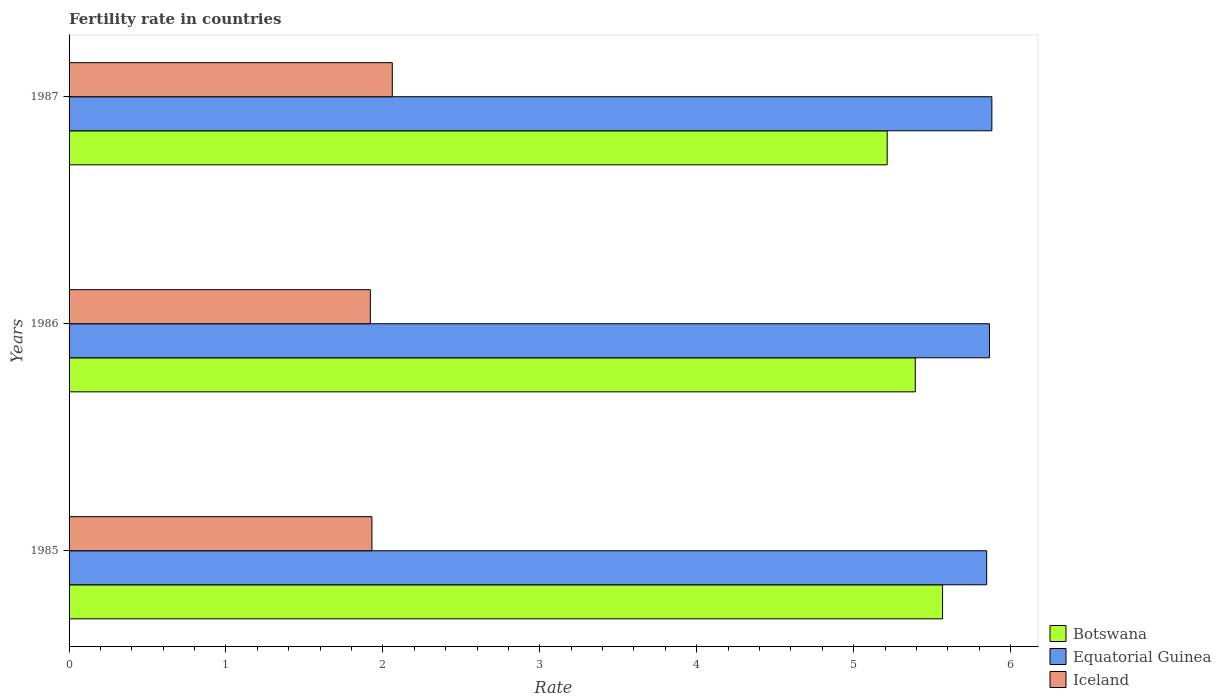How many different coloured bars are there?
Your answer should be compact. 3. How many groups of bars are there?
Keep it short and to the point. 3. What is the fertility rate in Iceland in 1985?
Offer a terse response. 1.93. Across all years, what is the maximum fertility rate in Botswana?
Ensure brevity in your answer.  5.57. Across all years, what is the minimum fertility rate in Equatorial Guinea?
Your response must be concise. 5.85. In which year was the fertility rate in Iceland minimum?
Your response must be concise. 1986. What is the total fertility rate in Iceland in the graph?
Your answer should be compact. 5.91. What is the difference between the fertility rate in Iceland in 1985 and that in 1987?
Offer a very short reply. -0.13. What is the difference between the fertility rate in Botswana in 1987 and the fertility rate in Iceland in 1985?
Keep it short and to the point. 3.28. What is the average fertility rate in Equatorial Guinea per year?
Make the answer very short. 5.87. In the year 1987, what is the difference between the fertility rate in Equatorial Guinea and fertility rate in Botswana?
Offer a very short reply. 0.67. In how many years, is the fertility rate in Equatorial Guinea greater than 4.8 ?
Ensure brevity in your answer.  3. What is the ratio of the fertility rate in Iceland in 1985 to that in 1986?
Provide a short and direct response. 1.01. Is the fertility rate in Botswana in 1985 less than that in 1986?
Ensure brevity in your answer.  No. Is the difference between the fertility rate in Equatorial Guinea in 1986 and 1987 greater than the difference between the fertility rate in Botswana in 1986 and 1987?
Ensure brevity in your answer.  No. What is the difference between the highest and the second highest fertility rate in Iceland?
Your answer should be compact. 0.13. What is the difference between the highest and the lowest fertility rate in Botswana?
Give a very brief answer. 0.35. In how many years, is the fertility rate in Equatorial Guinea greater than the average fertility rate in Equatorial Guinea taken over all years?
Offer a very short reply. 2. Is the sum of the fertility rate in Botswana in 1986 and 1987 greater than the maximum fertility rate in Equatorial Guinea across all years?
Offer a very short reply. Yes. What does the 2nd bar from the top in 1987 represents?
Keep it short and to the point. Equatorial Guinea. What does the 1st bar from the bottom in 1986 represents?
Offer a terse response. Botswana. Is it the case that in every year, the sum of the fertility rate in Iceland and fertility rate in Botswana is greater than the fertility rate in Equatorial Guinea?
Your answer should be compact. Yes. How many bars are there?
Ensure brevity in your answer.  9. Are all the bars in the graph horizontal?
Offer a terse response. Yes. What is the difference between two consecutive major ticks on the X-axis?
Give a very brief answer. 1. Are the values on the major ticks of X-axis written in scientific E-notation?
Provide a succinct answer. No. What is the title of the graph?
Your answer should be very brief. Fertility rate in countries. What is the label or title of the X-axis?
Keep it short and to the point. Rate. What is the label or title of the Y-axis?
Give a very brief answer. Years. What is the Rate in Botswana in 1985?
Provide a short and direct response. 5.57. What is the Rate in Equatorial Guinea in 1985?
Offer a very short reply. 5.85. What is the Rate of Iceland in 1985?
Offer a very short reply. 1.93. What is the Rate in Botswana in 1986?
Keep it short and to the point. 5.39. What is the Rate in Equatorial Guinea in 1986?
Your answer should be very brief. 5.87. What is the Rate in Iceland in 1986?
Provide a succinct answer. 1.92. What is the Rate in Botswana in 1987?
Provide a short and direct response. 5.21. What is the Rate in Equatorial Guinea in 1987?
Provide a succinct answer. 5.88. What is the Rate of Iceland in 1987?
Make the answer very short. 2.06. Across all years, what is the maximum Rate in Botswana?
Make the answer very short. 5.57. Across all years, what is the maximum Rate in Equatorial Guinea?
Your answer should be very brief. 5.88. Across all years, what is the maximum Rate in Iceland?
Ensure brevity in your answer.  2.06. Across all years, what is the minimum Rate in Botswana?
Your answer should be very brief. 5.21. Across all years, what is the minimum Rate in Equatorial Guinea?
Provide a short and direct response. 5.85. Across all years, what is the minimum Rate in Iceland?
Provide a succinct answer. 1.92. What is the total Rate in Botswana in the graph?
Provide a succinct answer. 16.17. What is the total Rate in Equatorial Guinea in the graph?
Provide a succinct answer. 17.59. What is the total Rate in Iceland in the graph?
Give a very brief answer. 5.91. What is the difference between the Rate in Botswana in 1985 and that in 1986?
Your response must be concise. 0.17. What is the difference between the Rate in Equatorial Guinea in 1985 and that in 1986?
Your answer should be very brief. -0.02. What is the difference between the Rate of Iceland in 1985 and that in 1986?
Your response must be concise. 0.01. What is the difference between the Rate of Botswana in 1985 and that in 1987?
Give a very brief answer. 0.35. What is the difference between the Rate in Equatorial Guinea in 1985 and that in 1987?
Ensure brevity in your answer.  -0.03. What is the difference between the Rate in Iceland in 1985 and that in 1987?
Offer a very short reply. -0.13. What is the difference between the Rate in Botswana in 1986 and that in 1987?
Provide a succinct answer. 0.18. What is the difference between the Rate of Equatorial Guinea in 1986 and that in 1987?
Give a very brief answer. -0.01. What is the difference between the Rate of Iceland in 1986 and that in 1987?
Provide a short and direct response. -0.14. What is the difference between the Rate in Botswana in 1985 and the Rate in Equatorial Guinea in 1986?
Keep it short and to the point. -0.3. What is the difference between the Rate in Botswana in 1985 and the Rate in Iceland in 1986?
Provide a succinct answer. 3.65. What is the difference between the Rate in Equatorial Guinea in 1985 and the Rate in Iceland in 1986?
Give a very brief answer. 3.93. What is the difference between the Rate in Botswana in 1985 and the Rate in Equatorial Guinea in 1987?
Provide a succinct answer. -0.31. What is the difference between the Rate in Botswana in 1985 and the Rate in Iceland in 1987?
Provide a succinct answer. 3.51. What is the difference between the Rate of Equatorial Guinea in 1985 and the Rate of Iceland in 1987?
Ensure brevity in your answer.  3.79. What is the difference between the Rate of Botswana in 1986 and the Rate of Equatorial Guinea in 1987?
Your response must be concise. -0.49. What is the difference between the Rate in Botswana in 1986 and the Rate in Iceland in 1987?
Your answer should be compact. 3.33. What is the difference between the Rate of Equatorial Guinea in 1986 and the Rate of Iceland in 1987?
Keep it short and to the point. 3.81. What is the average Rate of Botswana per year?
Make the answer very short. 5.39. What is the average Rate of Equatorial Guinea per year?
Make the answer very short. 5.87. What is the average Rate in Iceland per year?
Offer a very short reply. 1.97. In the year 1985, what is the difference between the Rate of Botswana and Rate of Equatorial Guinea?
Offer a terse response. -0.28. In the year 1985, what is the difference between the Rate of Botswana and Rate of Iceland?
Give a very brief answer. 3.64. In the year 1985, what is the difference between the Rate in Equatorial Guinea and Rate in Iceland?
Make the answer very short. 3.92. In the year 1986, what is the difference between the Rate in Botswana and Rate in Equatorial Guinea?
Ensure brevity in your answer.  -0.47. In the year 1986, what is the difference between the Rate in Botswana and Rate in Iceland?
Offer a very short reply. 3.47. In the year 1986, what is the difference between the Rate in Equatorial Guinea and Rate in Iceland?
Ensure brevity in your answer.  3.95. In the year 1987, what is the difference between the Rate of Botswana and Rate of Equatorial Guinea?
Offer a very short reply. -0.67. In the year 1987, what is the difference between the Rate in Botswana and Rate in Iceland?
Offer a very short reply. 3.15. In the year 1987, what is the difference between the Rate of Equatorial Guinea and Rate of Iceland?
Your response must be concise. 3.82. What is the ratio of the Rate in Botswana in 1985 to that in 1986?
Provide a succinct answer. 1.03. What is the ratio of the Rate of Iceland in 1985 to that in 1986?
Ensure brevity in your answer.  1.01. What is the ratio of the Rate in Botswana in 1985 to that in 1987?
Ensure brevity in your answer.  1.07. What is the ratio of the Rate in Equatorial Guinea in 1985 to that in 1987?
Your response must be concise. 0.99. What is the ratio of the Rate in Iceland in 1985 to that in 1987?
Your answer should be very brief. 0.94. What is the ratio of the Rate of Botswana in 1986 to that in 1987?
Your response must be concise. 1.03. What is the ratio of the Rate in Iceland in 1986 to that in 1987?
Provide a succinct answer. 0.93. What is the difference between the highest and the second highest Rate in Botswana?
Provide a succinct answer. 0.17. What is the difference between the highest and the second highest Rate in Equatorial Guinea?
Ensure brevity in your answer.  0.01. What is the difference between the highest and the second highest Rate in Iceland?
Your response must be concise. 0.13. What is the difference between the highest and the lowest Rate in Botswana?
Your answer should be very brief. 0.35. What is the difference between the highest and the lowest Rate in Equatorial Guinea?
Your answer should be very brief. 0.03. What is the difference between the highest and the lowest Rate in Iceland?
Provide a short and direct response. 0.14. 